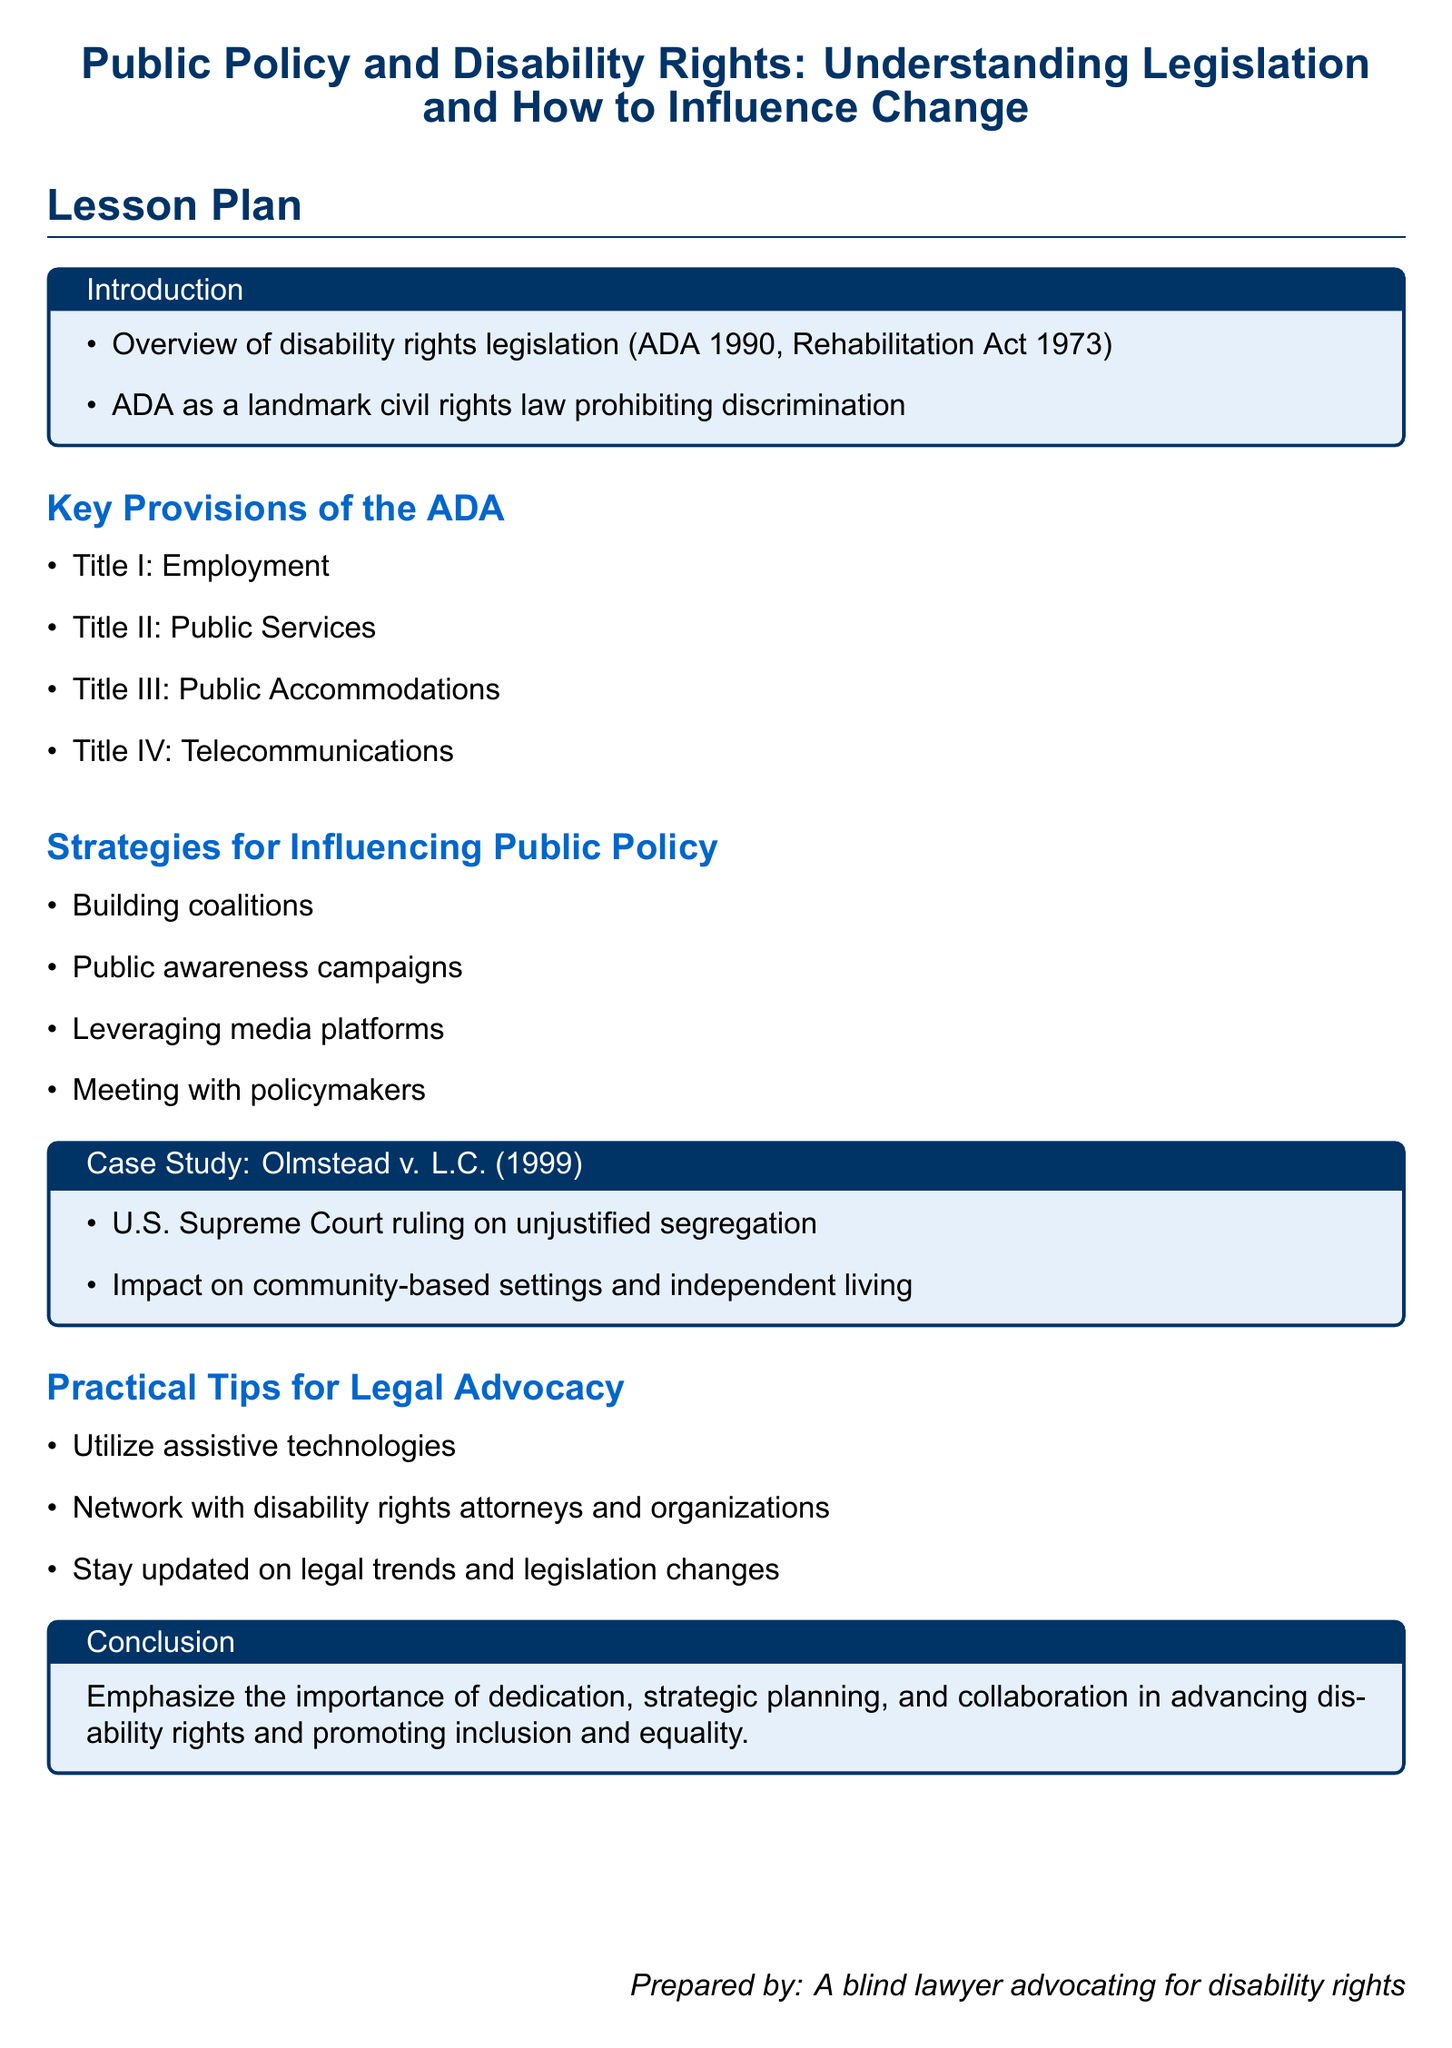What landmark law prohibits discrimination based on disability? The Americans with Disabilities Act (ADA) of 1990 is highlighted as a landmark civil rights law prohibiting discrimination.
Answer: Americans with Disabilities Act (ADA) How many titles are there in the ADA? The document lists four key titles of the ADA, indicating the main areas covered by the act.
Answer: Four What year was the Rehabilitation Act enacted? The document mentions the Rehabilitation Act of 1973 as one of the key pieces of disability rights legislation.
Answer: 1973 What is one strategy for influencing public policy mentioned? The document outlines several strategies, one of which is building coalitions to influence public policy.
Answer: Building coalitions What was the significant ruling in Olmstead v. L.C. (1999)? The case study highlights the U.S. Supreme Court ruling on unjustified segregation and its impact on living settings for people with disabilities.
Answer: Unjustified segregation What is emphasized in the conclusion of the lesson plan? The conclusion summarizes the importance of dedication, strategic planning, and collaboration in advancing disability rights.
Answer: Dedication, strategic planning, collaboration 